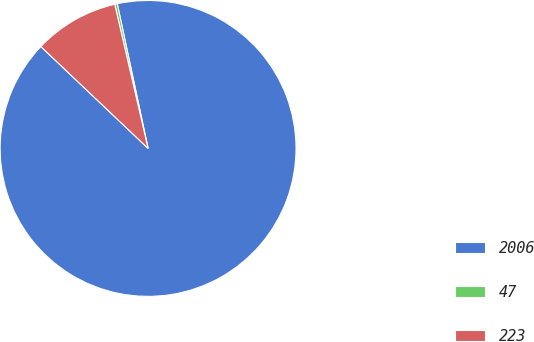Convert chart. <chart><loc_0><loc_0><loc_500><loc_500><pie_chart><fcel>2006<fcel>47<fcel>223<nl><fcel>90.43%<fcel>0.28%<fcel>9.29%<nl></chart> 